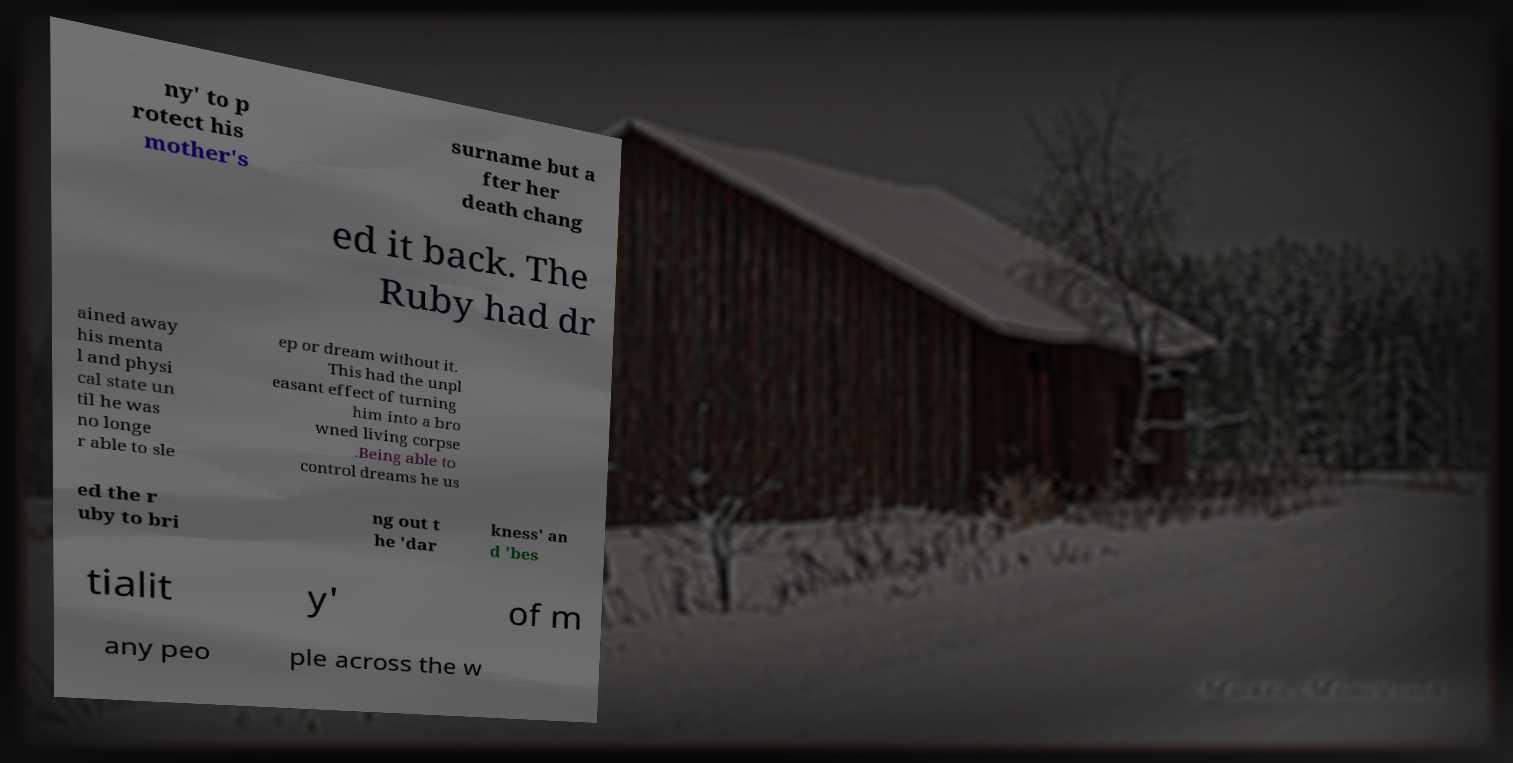Can you accurately transcribe the text from the provided image for me? ny' to p rotect his mother's surname but a fter her death chang ed it back. The Ruby had dr ained away his menta l and physi cal state un til he was no longe r able to sle ep or dream without it. This had the unpl easant effect of turning him into a bro wned living corpse .Being able to control dreams he us ed the r uby to bri ng out t he 'dar kness' an d 'bes tialit y' of m any peo ple across the w 